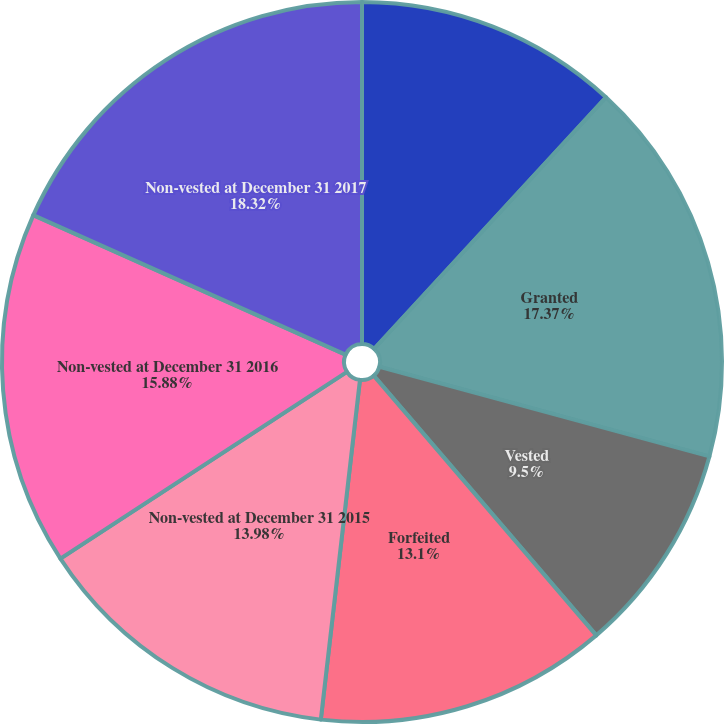<chart> <loc_0><loc_0><loc_500><loc_500><pie_chart><fcel>Non-vested at December 31 2014<fcel>Granted<fcel>Vested<fcel>Forfeited<fcel>Non-vested at December 31 2015<fcel>Non-vested at December 31 2016<fcel>Non-vested at December 31 2017<nl><fcel>11.85%<fcel>17.37%<fcel>9.5%<fcel>13.1%<fcel>13.98%<fcel>15.88%<fcel>18.31%<nl></chart> 